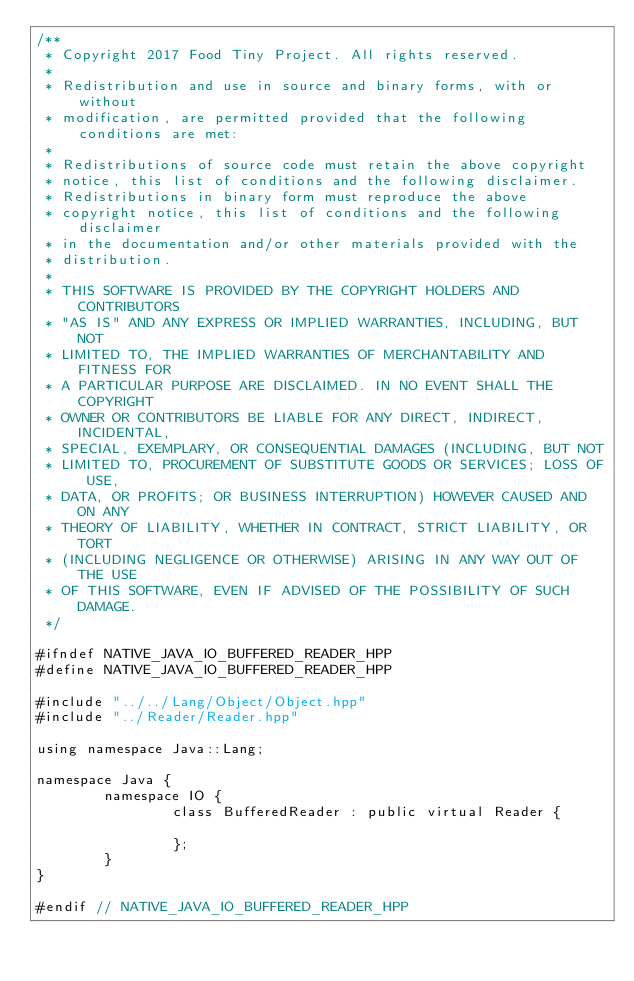Convert code to text. <code><loc_0><loc_0><loc_500><loc_500><_C++_>/**
 * Copyright 2017 Food Tiny Project. All rights reserved.
 *
 * Redistribution and use in source and binary forms, with or without
 * modification, are permitted provided that the following conditions are met:
 *
 * Redistributions of source code must retain the above copyright
 * notice, this list of conditions and the following disclaimer.
 * Redistributions in binary form must reproduce the above
 * copyright notice, this list of conditions and the following disclaimer
 * in the documentation and/or other materials provided with the
 * distribution.
 *
 * THIS SOFTWARE IS PROVIDED BY THE COPYRIGHT HOLDERS AND CONTRIBUTORS
 * "AS IS" AND ANY EXPRESS OR IMPLIED WARRANTIES, INCLUDING, BUT NOT
 * LIMITED TO, THE IMPLIED WARRANTIES OF MERCHANTABILITY AND FITNESS FOR
 * A PARTICULAR PURPOSE ARE DISCLAIMED. IN NO EVENT SHALL THE COPYRIGHT
 * OWNER OR CONTRIBUTORS BE LIABLE FOR ANY DIRECT, INDIRECT, INCIDENTAL,
 * SPECIAL, EXEMPLARY, OR CONSEQUENTIAL DAMAGES (INCLUDING, BUT NOT
 * LIMITED TO, PROCUREMENT OF SUBSTITUTE GOODS OR SERVICES; LOSS OF USE,
 * DATA, OR PROFITS; OR BUSINESS INTERRUPTION) HOWEVER CAUSED AND ON ANY
 * THEORY OF LIABILITY, WHETHER IN CONTRACT, STRICT LIABILITY, OR TORT
 * (INCLUDING NEGLIGENCE OR OTHERWISE) ARISING IN ANY WAY OUT OF THE USE
 * OF THIS SOFTWARE, EVEN IF ADVISED OF THE POSSIBILITY OF SUCH DAMAGE.
 */

#ifndef NATIVE_JAVA_IO_BUFFERED_READER_HPP
#define NATIVE_JAVA_IO_BUFFERED_READER_HPP

#include "../../Lang/Object/Object.hpp"
#include "../Reader/Reader.hpp"

using namespace Java::Lang;

namespace Java {
		namespace IO {
				class BufferedReader : public virtual Reader {
				
				};
		}
}

#endif // NATIVE_JAVA_IO_BUFFERED_READER_HPP</code> 